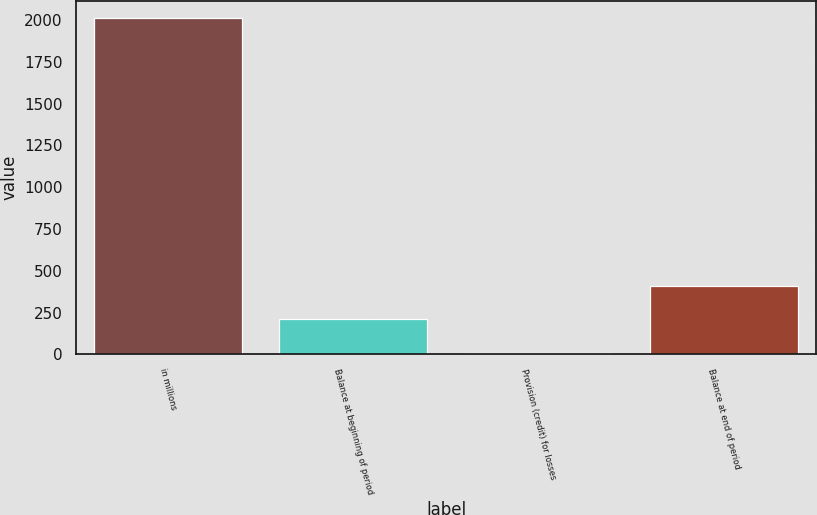<chart> <loc_0><loc_0><loc_500><loc_500><bar_chart><fcel>in millions<fcel>Balance at beginning of period<fcel>Provision (credit) for losses<fcel>Balance at end of period<nl><fcel>2013<fcel>208.5<fcel>8<fcel>409<nl></chart> 